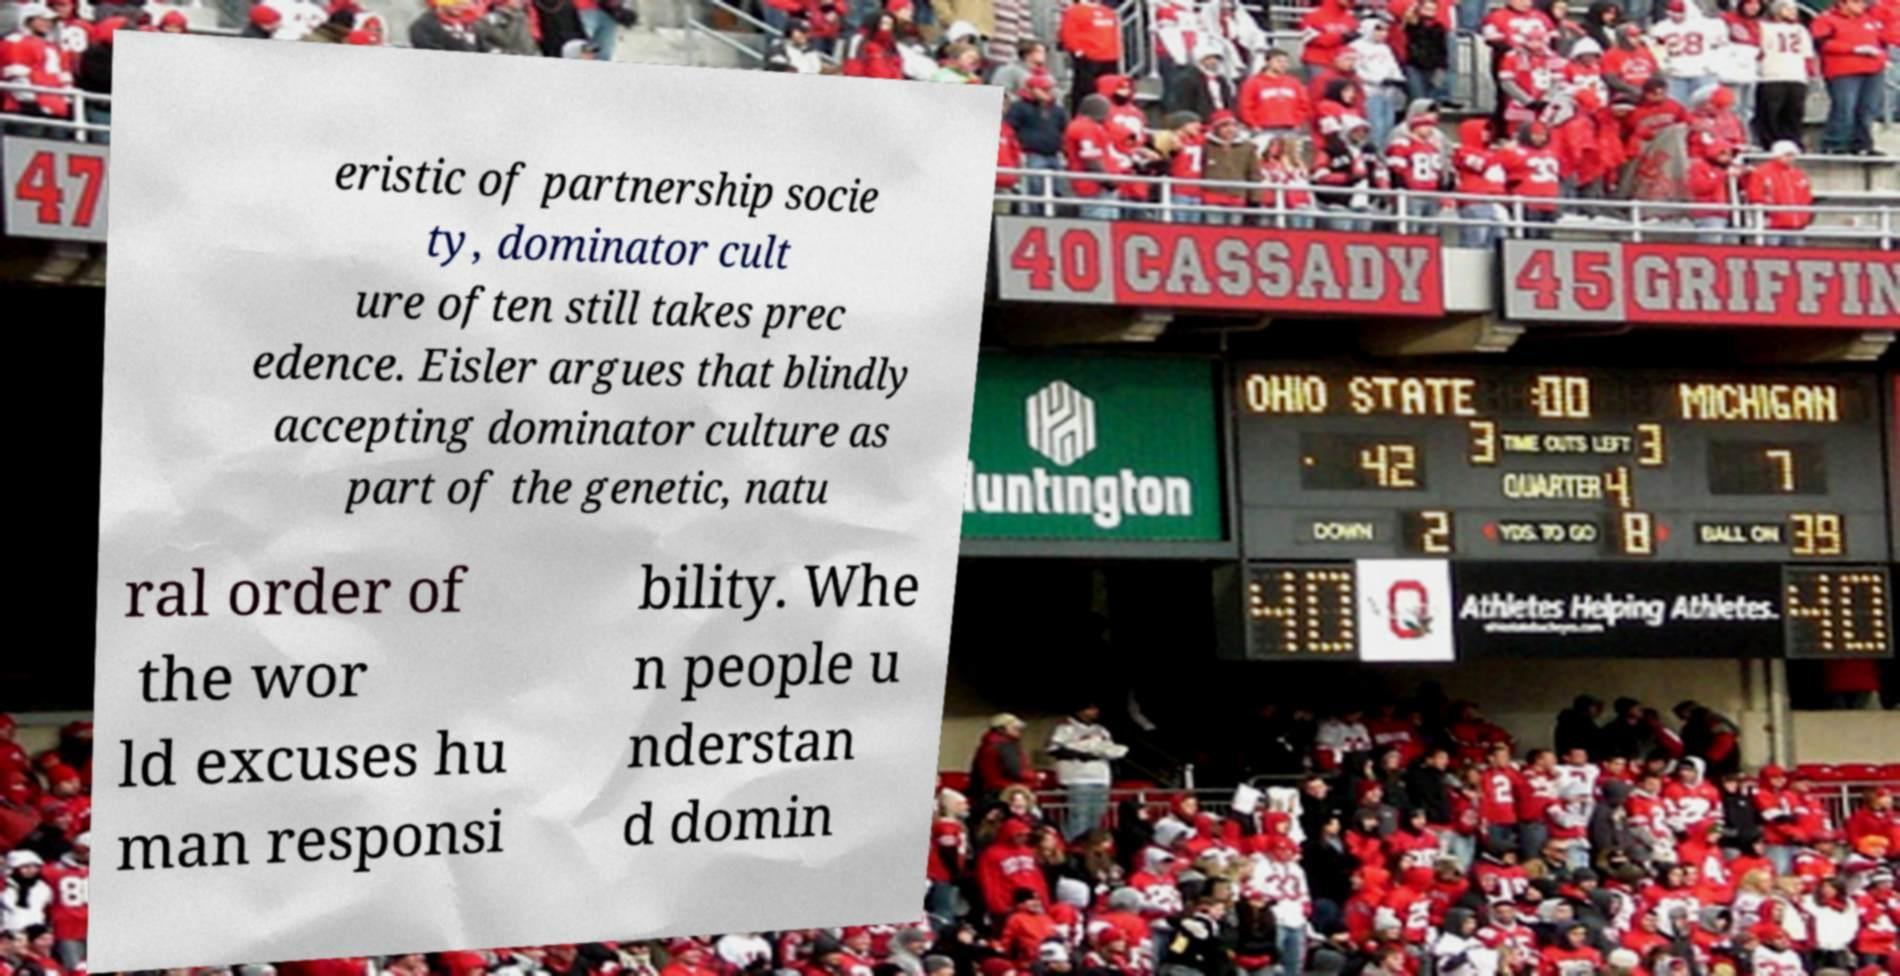There's text embedded in this image that I need extracted. Can you transcribe it verbatim? eristic of partnership socie ty, dominator cult ure often still takes prec edence. Eisler argues that blindly accepting dominator culture as part of the genetic, natu ral order of the wor ld excuses hu man responsi bility. Whe n people u nderstan d domin 